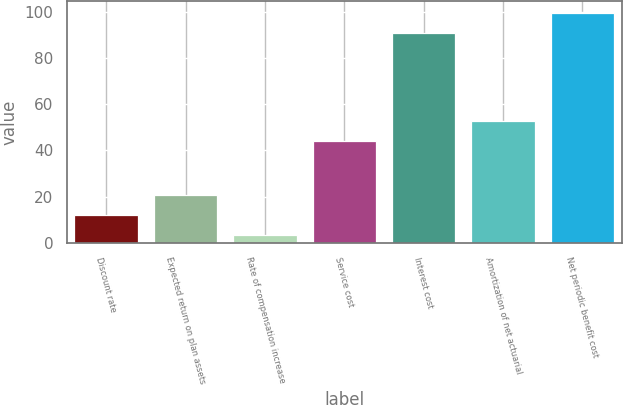Convert chart to OTSL. <chart><loc_0><loc_0><loc_500><loc_500><bar_chart><fcel>Discount rate<fcel>Expected return on plan assets<fcel>Rate of compensation increase<fcel>Service cost<fcel>Interest cost<fcel>Amortization of net actuarial<fcel>Net periodic benefit cost<nl><fcel>12.03<fcel>20.8<fcel>3.25<fcel>44<fcel>91<fcel>52.77<fcel>99.78<nl></chart> 